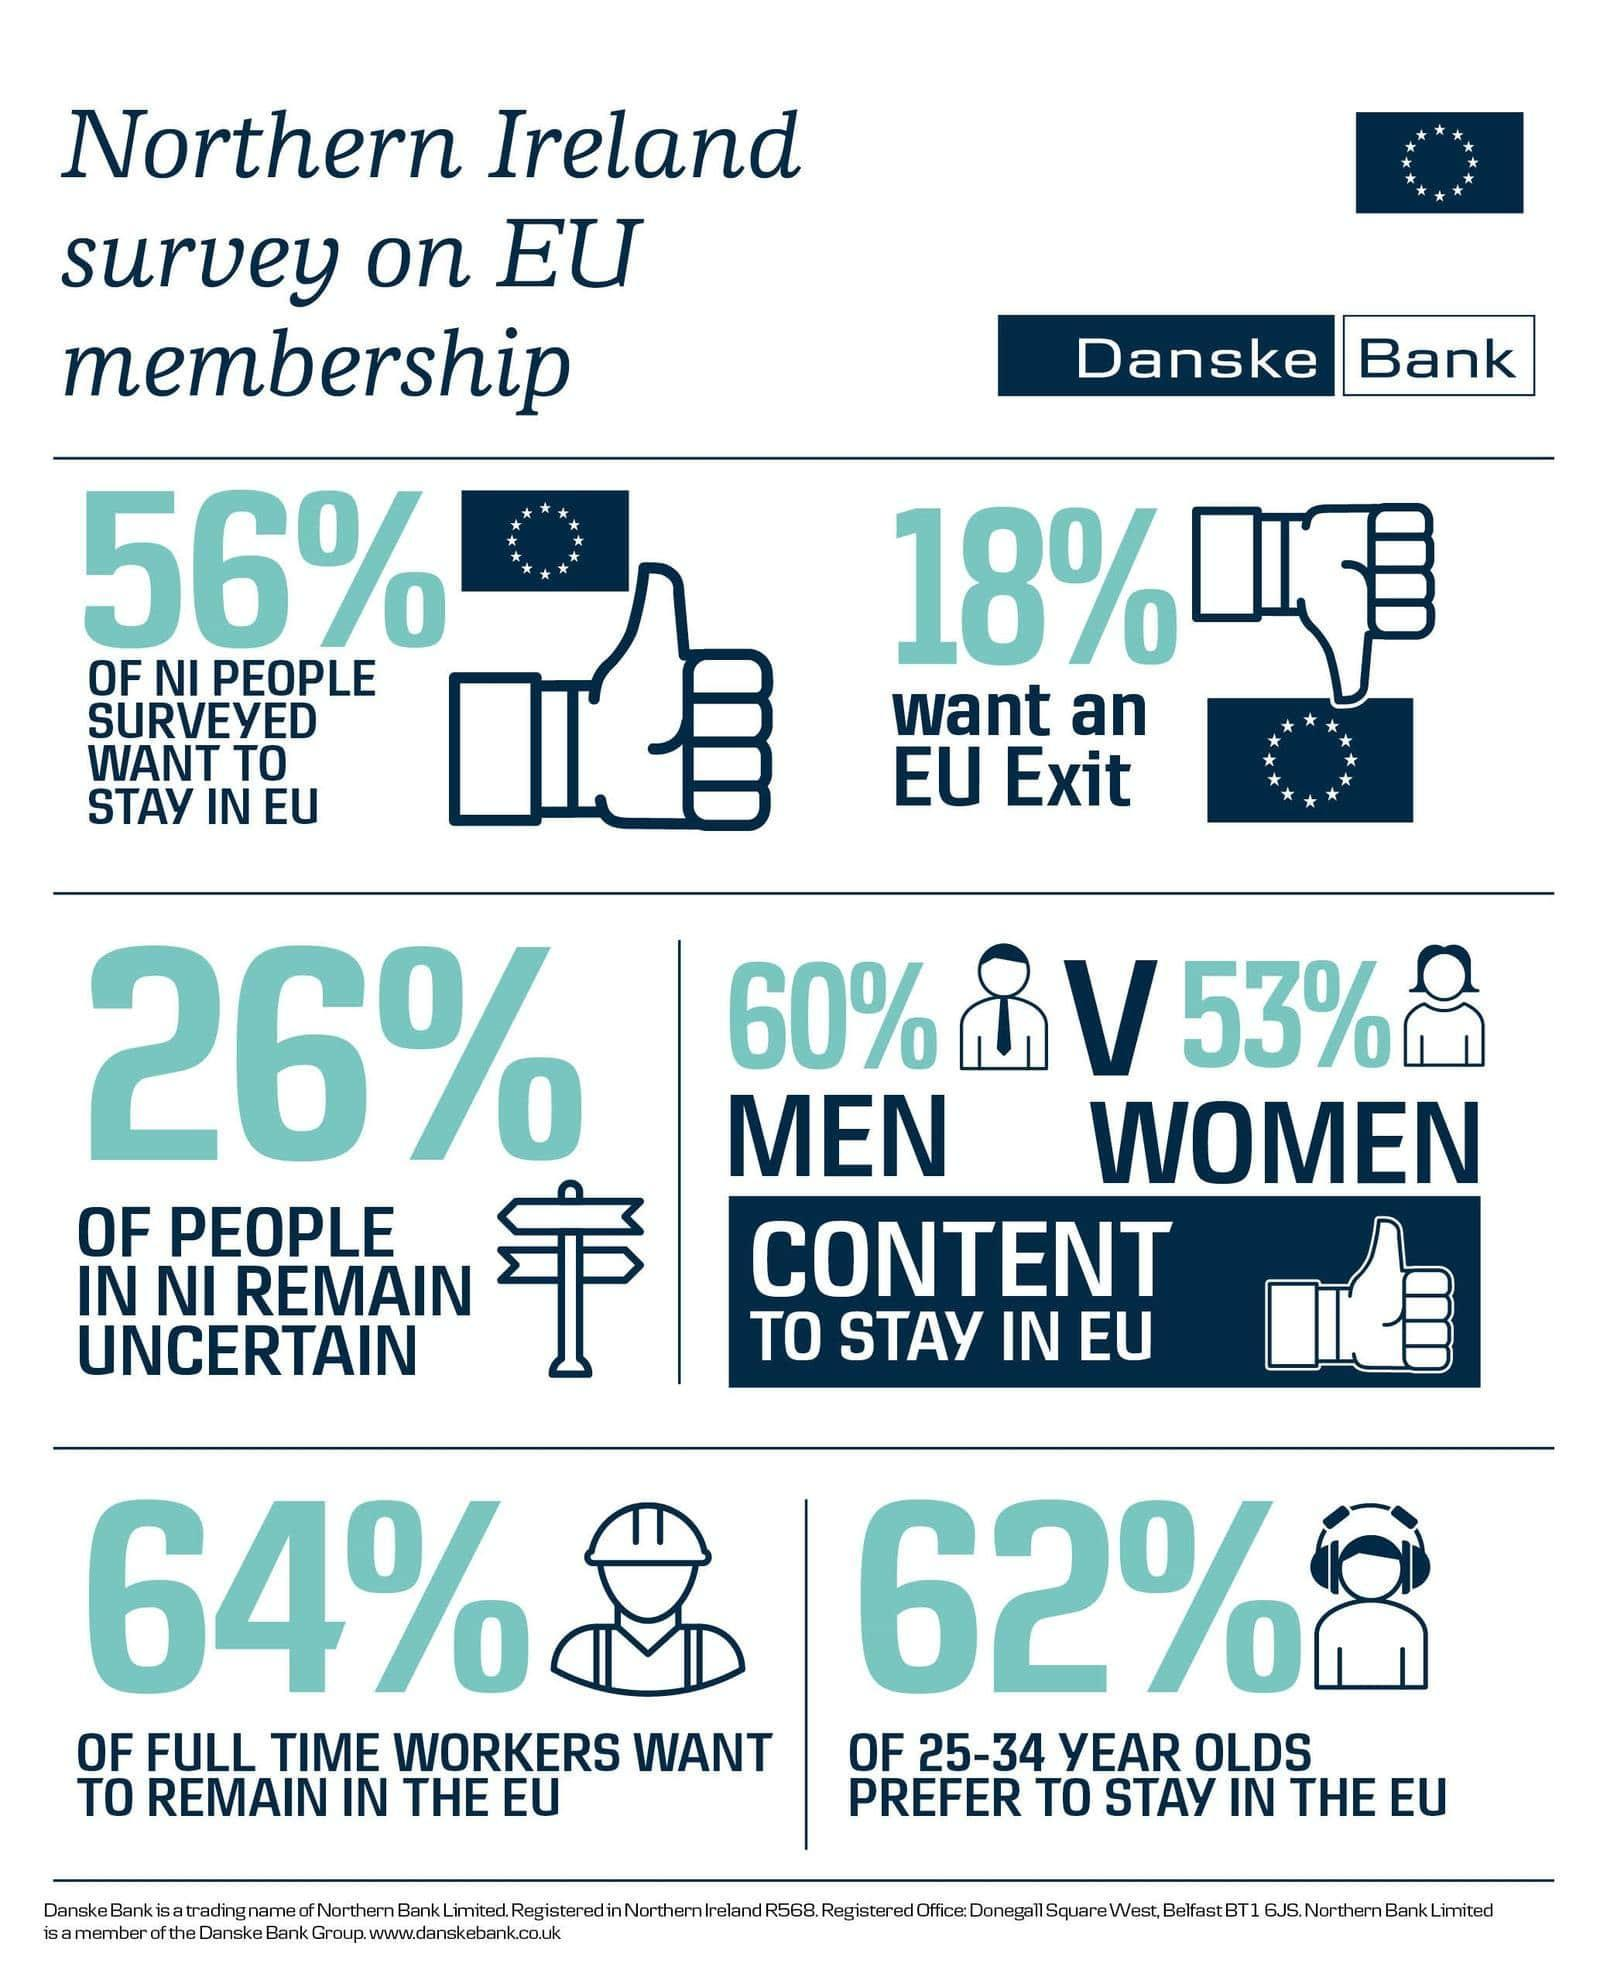What percentage of people in Northern Ireland surveyed want an EU exit?
Answer the question with a short phrase. 18% What percentage of full time workers in Northern Ireland  want to remain in the EU? 64% What percentage of people aged 25-34 years in Northern Ireland prefer to stay in the EU? 62% What  percentage of people in Northern Ireland remain uncertain? 26% 